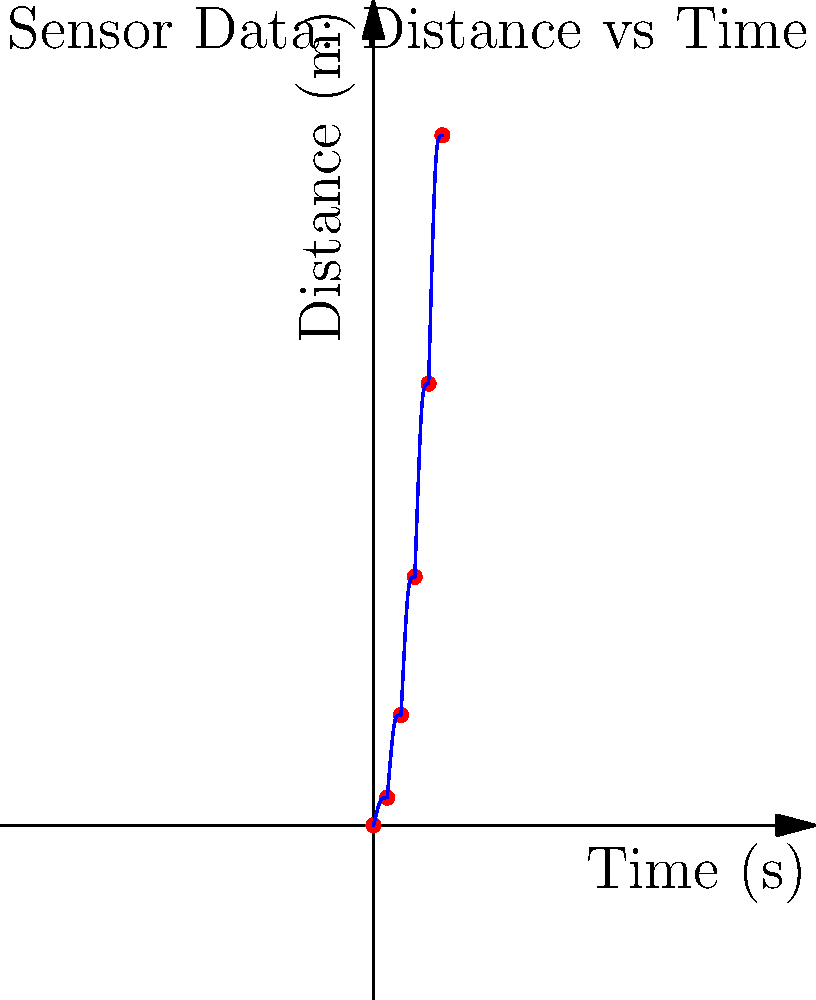As a program officer evaluating robotics projects, you come across a sensor data visualization from an autonomous vehicle. The graph shows the relationship between time and distance traveled. What can you infer about the vehicle's motion based on the shape of the curve, and how might this information be relevant when assessing the effectiveness of the vehicle's navigation system? To analyze this graph and its implications for an autonomous vehicle's navigation system, let's break it down step-by-step:

1. Graph interpretation:
   - The x-axis represents time in seconds, and the y-axis represents distance in meters.
   - The curve is not linear but shows an increasing slope over time.

2. Motion analysis:
   - The increasing slope indicates that the vehicle's velocity is increasing over time.
   - This suggests the vehicle is accelerating throughout the observed period.

3. Mathematical representation:
   - The relationship between distance (d), time (t), and acceleration (a) for constant acceleration is given by the equation:
     $$ d = \frac{1}{2}at^2 + v_0t + d_0 $$
   where $v_0$ is initial velocity and $d_0$ is initial position.

4. Curve shape:
   - The curve resembles a parabola, which is consistent with the quadratic equation for constant acceleration.
   - This suggests the vehicle is likely maintaining a constant acceleration.

5. Implications for navigation:
   - Constant acceleration may indicate smooth and controlled motion, which is desirable for autonomous vehicles.
   - The ability to maintain constant acceleration could suggest effective motor control and path planning.

6. Relevance to project evaluation:
   - This data visualization demonstrates the vehicle's capability to execute controlled acceleration.
   - It provides insights into the precision of the vehicle's motion control systems.
   - The smooth curve suggests minimal jerky movements, which is important for passenger comfort and safety.

7. Considerations for further evaluation:
   - While this data shows controlled acceleration, it's important to also assess how the vehicle handles deceleration and maintaining constant speed.
   - The project should be evaluated on how well the navigation system adapts to different scenarios, not just straight-line acceleration.

8. Sensor accuracy:
   - The smoothness of the curve also reflects on the accuracy and consistency of the vehicle's sensors in measuring distance over time.
   - High-quality sensor data is crucial for effective navigation and decision-making in autonomous vehicles.
Answer: The vehicle is undergoing constant acceleration, indicating smooth motion control and effective sensor data collection, which are crucial for autonomous navigation systems. 